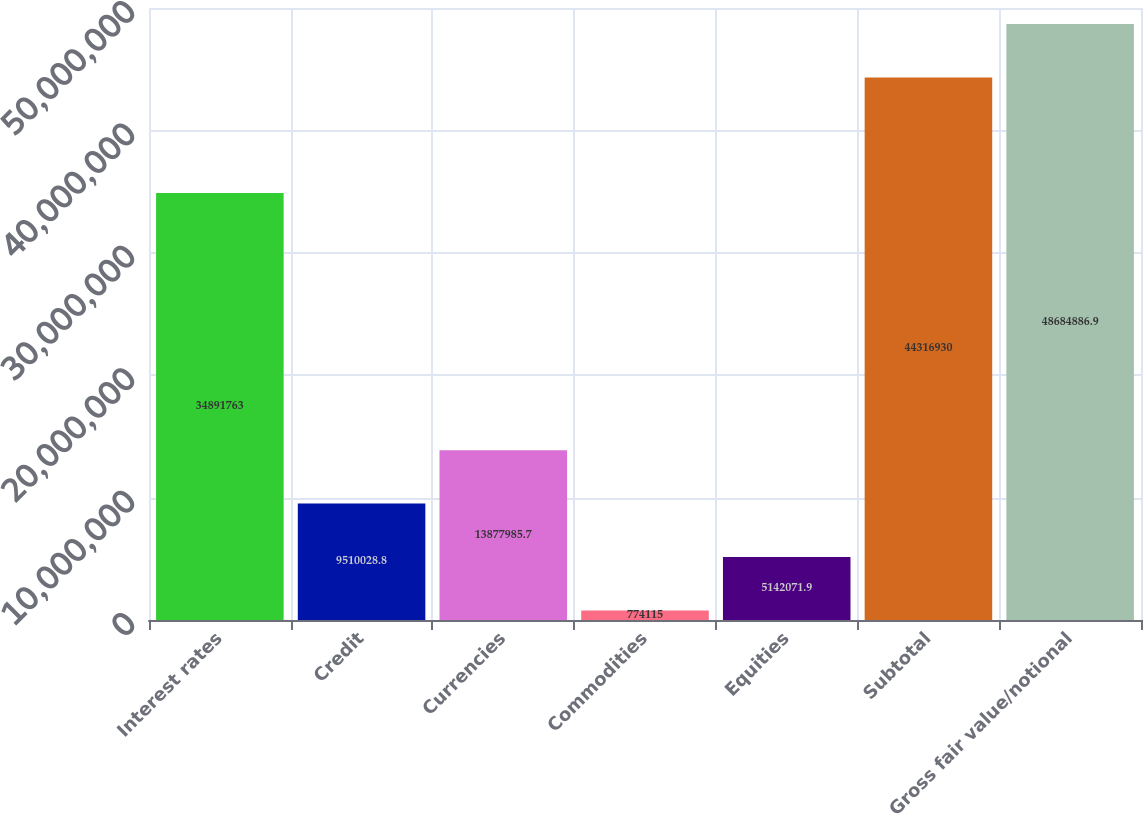<chart> <loc_0><loc_0><loc_500><loc_500><bar_chart><fcel>Interest rates<fcel>Credit<fcel>Currencies<fcel>Commodities<fcel>Equities<fcel>Subtotal<fcel>Gross fair value/notional<nl><fcel>3.48918e+07<fcel>9.51003e+06<fcel>1.3878e+07<fcel>774115<fcel>5.14207e+06<fcel>4.43169e+07<fcel>4.86849e+07<nl></chart> 